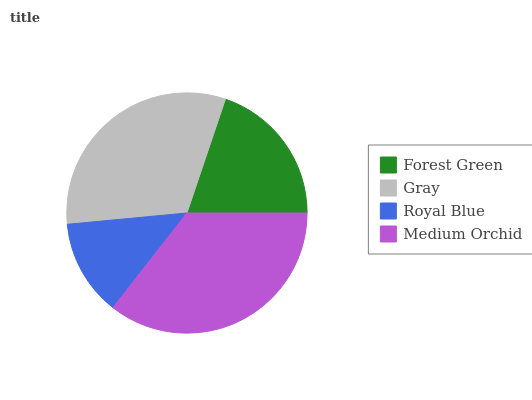Is Royal Blue the minimum?
Answer yes or no. Yes. Is Medium Orchid the maximum?
Answer yes or no. Yes. Is Gray the minimum?
Answer yes or no. No. Is Gray the maximum?
Answer yes or no. No. Is Gray greater than Forest Green?
Answer yes or no. Yes. Is Forest Green less than Gray?
Answer yes or no. Yes. Is Forest Green greater than Gray?
Answer yes or no. No. Is Gray less than Forest Green?
Answer yes or no. No. Is Gray the high median?
Answer yes or no. Yes. Is Forest Green the low median?
Answer yes or no. Yes. Is Medium Orchid the high median?
Answer yes or no. No. Is Medium Orchid the low median?
Answer yes or no. No. 